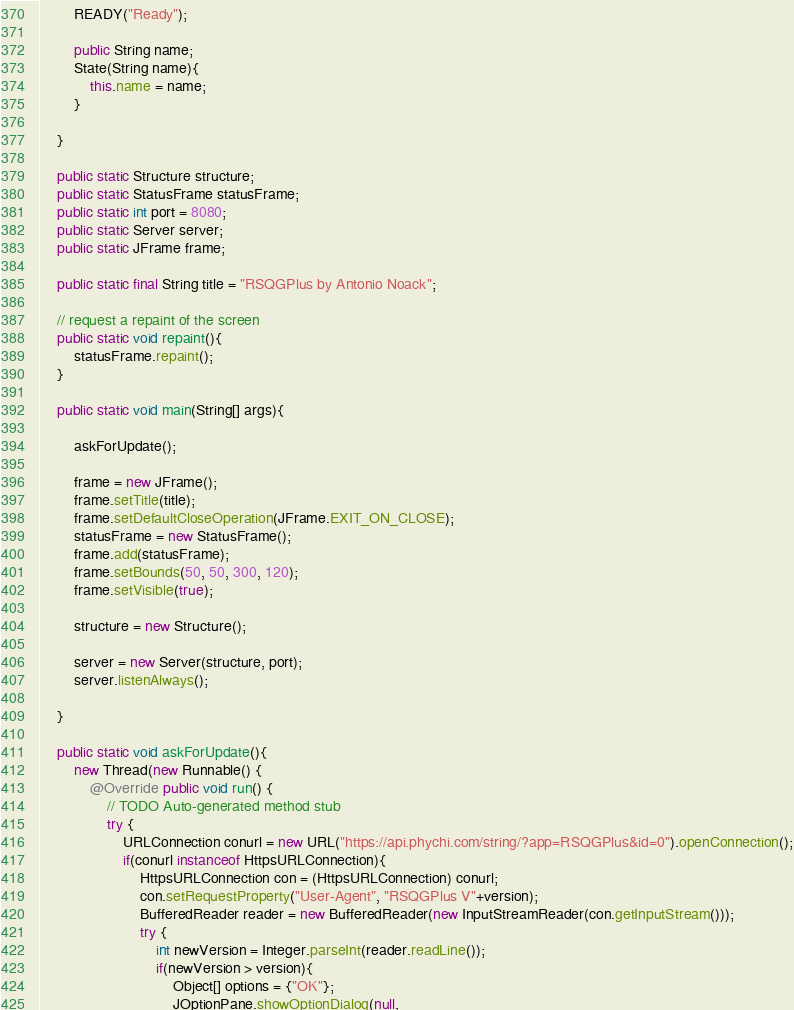Convert code to text. <code><loc_0><loc_0><loc_500><loc_500><_Java_>		READY("Ready");
		
		public String name;
		State(String name){
			this.name = name;
		}
		
	}
	
	public static Structure structure;
	public static StatusFrame statusFrame;
	public static int port = 8080;
	public static Server server;
	public static JFrame frame;
	
	public static final String title = "RSQGPlus by Antonio Noack";
	
	// request a repaint of the screen
	public static void repaint(){
		statusFrame.repaint();
	}

	public static void main(String[] args){
		
		askForUpdate();

		frame = new JFrame();
		frame.setTitle(title);
		frame.setDefaultCloseOperation(JFrame.EXIT_ON_CLOSE);
		statusFrame = new StatusFrame();
		frame.add(statusFrame);
		frame.setBounds(50, 50, 300, 120);
		frame.setVisible(true);
		
		structure = new Structure();
		
		server = new Server(structure, port);
		server.listenAlways();
		
	}
	
	public static void askForUpdate(){
		new Thread(new Runnable() {
			@Override public void run() {
				// TODO Auto-generated method stub
				try {
					URLConnection conurl = new URL("https://api.phychi.com/string/?app=RSQGPlus&id=0").openConnection();
					if(conurl instanceof HttpsURLConnection){
						HttpsURLConnection con = (HttpsURLConnection) conurl;
						con.setRequestProperty("User-Agent", "RSQGPlus V"+version);
						BufferedReader reader = new BufferedReader(new InputStreamReader(con.getInputStream()));
						try {
							int newVersion = Integer.parseInt(reader.readLine());
							if(newVersion > version){
								Object[] options = {"OK"};
							    JOptionPane.showOptionDialog(null,</code> 